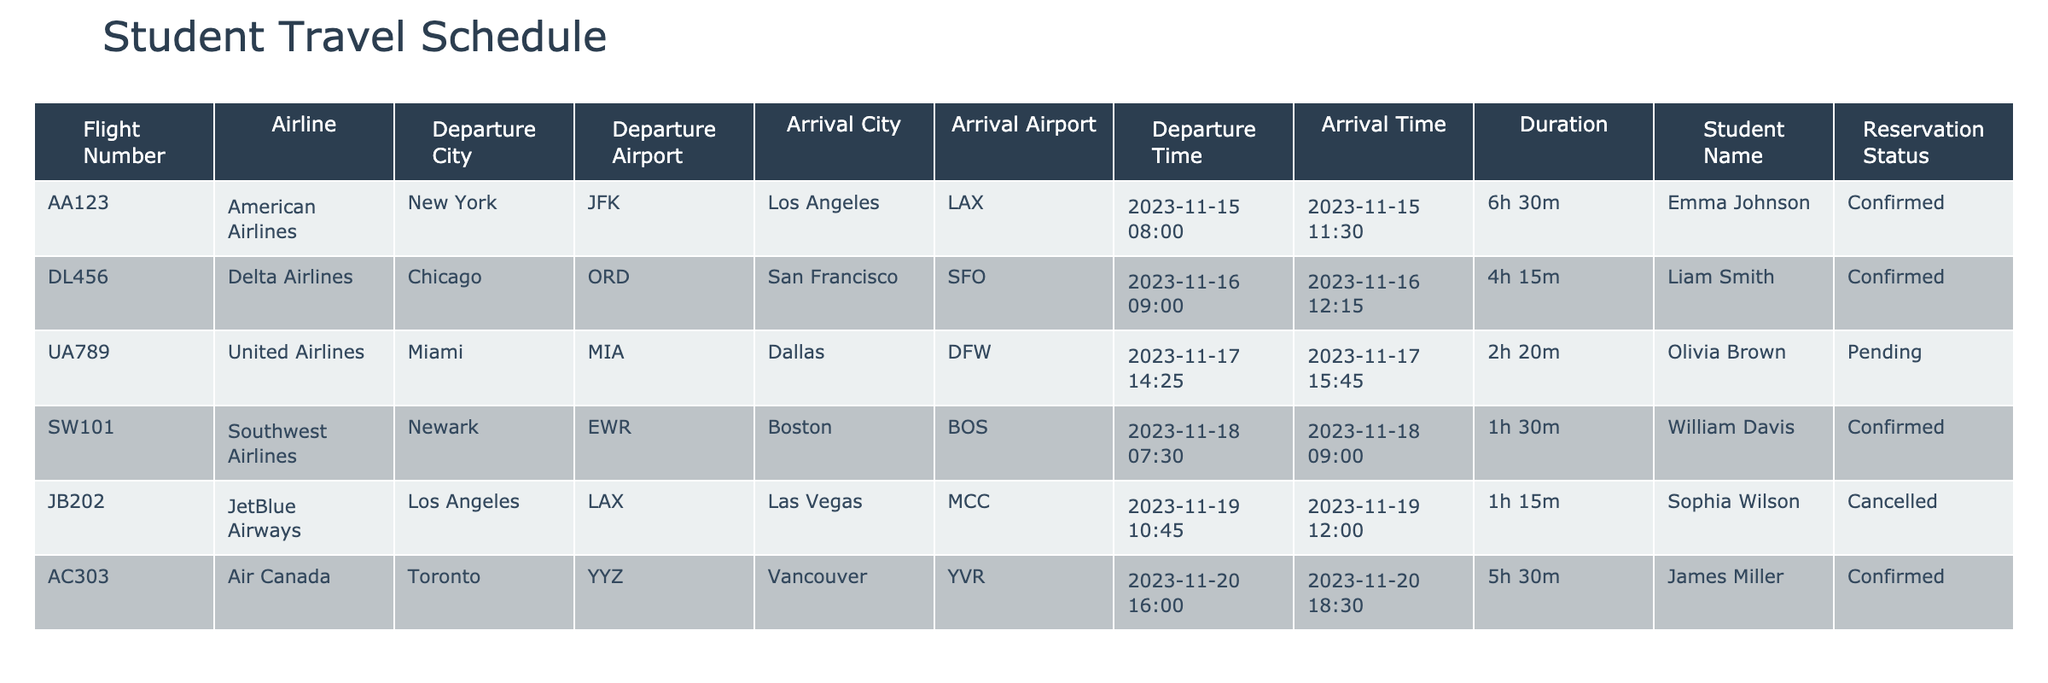What is the flight number for Emma Johnson's itinerary? In the table, I locate the row corresponding to Emma Johnson. The flight number listed next to her name is AA123.
Answer: AA123 Which airline is scheduled for William Davis's flight? I look at William Davis's row in the table and see that the airline for his flight is Southwest Airlines.
Answer: Southwest Airlines Are all flights in the itinerary confirmed? I examine the 'Reservation Status' column and notice that Olivia Brown's flight is pending and Sophia Wilson's flight is cancelled, indicating not all flights are confirmed.
Answer: No What is the total duration of all flights combined? I calculate the total duration by converting each flight duration to minutes: 390 (AA123) + 255 (DL456) + 140 (UA789, pending) + 90 (SW101) + 75 (JB202, cancelled) + 330 (AC303) = 1,280 minutes. Considered in hours and minutes, it converts to 21 hours and 20 minutes.
Answer: 21 hours 20 minutes Which student has the earliest departure time and what is the flight number? I scan the 'Departure Time' column and find the earliest date is for Emma Johnson, whose flight departs at 8:00 AM. Her flight number is AA123.
Answer: AA123, Emma Johnson What percentage of the flights are confirmed? There are 6 flights total and 4 of them are confirmed. I calculate the percentage as (4/6) * 100 = 66.67%.
Answer: 66.67% Which student has a flight to Las Vegas and what is the reservation status? I search through the table for flights to Las Vegas and find that Sophia Wilson has a flight there, and the reservation status is cancelled.
Answer: Cancelled How many flights are scheduled to depart before noon? I look through the 'Departure Time' column for flights departing before 12:00 PM. The flights for Emma Johnson (8:00 AM), Liam Smith (9:00 AM), and William Davis (7:30 AM) qualify, totaling 3 flights.
Answer: 3 